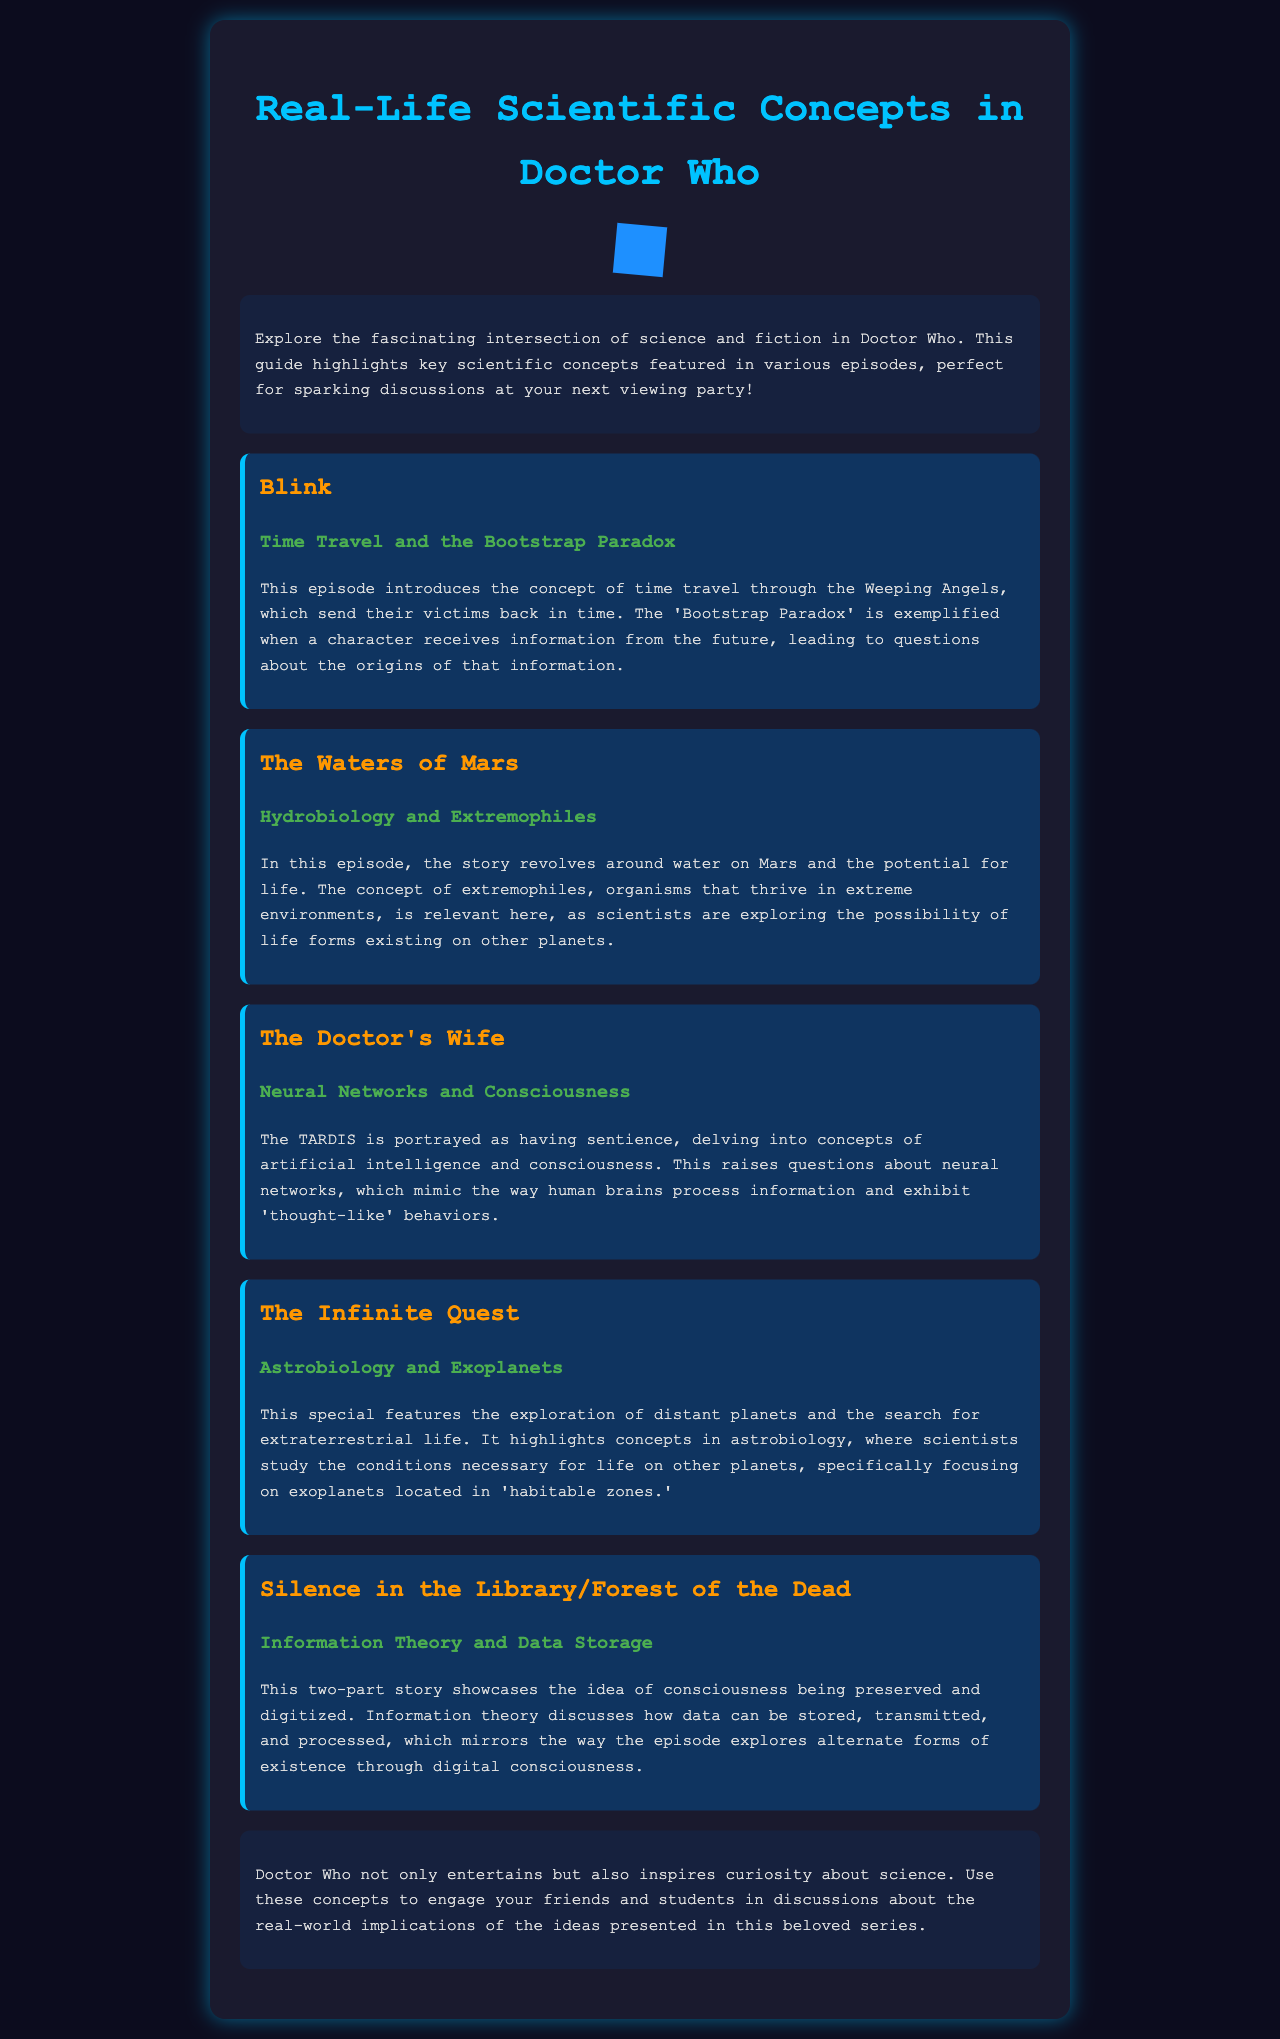what is the title of the brochure? The title of the brochure is prominently displayed at the top section, introducing the main theme.
Answer: Real-Life Scientific Concepts in Doctor Who what episode features the Bootstrap Paradox? The Bootstrap Paradox is discussed in the context of a specific episode that features time travel and Weeping Angels.
Answer: Blink what scientific concept is highlighted in "The Waters of Mars"? The episode explores a particular area of biology related to life forms in extreme environments.
Answer: Hydrobiology and Extremophiles which episode portrays the TARDIS as having sentience? The episode that delves into artificial intelligence through the portrayal of the TARDIS is mentioned under a specific title.
Answer: The Doctor's Wife how many episodes are discussed in the brochure? The number of episodes featured in the document provides a count of the individual entries.
Answer: five what is the main theme shared across the episodes? The episodes collectively address a central topic that links science and fiction throughout the discussions.
Answer: Scientific concepts which scientific topic involves studying life on exoplanets? The episode that discusses the exploration of distant planets relates to a specific scientific field.
Answer: Astrobiology what concept does the two-part story "Silence in the Library/Forest of the Dead" focus on? The concept discussed in this episode concerns the preservation and digitization of consciousness.
Answer: Information Theory and Data Storage what color is the background of the brochure? The background color throughout the brochure is consistent and is described in detail at the beginning of the document.
Answer: Dark blue 